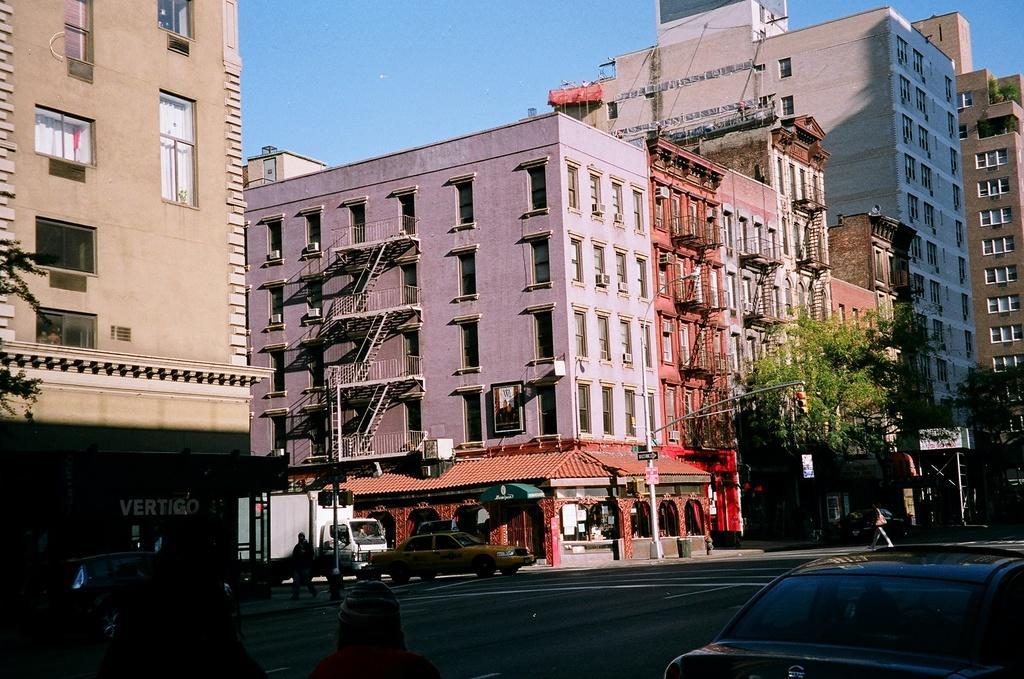Can you describe this image briefly? In this image, we can see few buildings with windows. Here we can see stairs, trees, walls, boards, pillars. At the bottom, there is a road, few vehicles we can see. Here we can see few people. Right side of the image, we can see a person is walking on the road. Top of the image, there is a sky. 